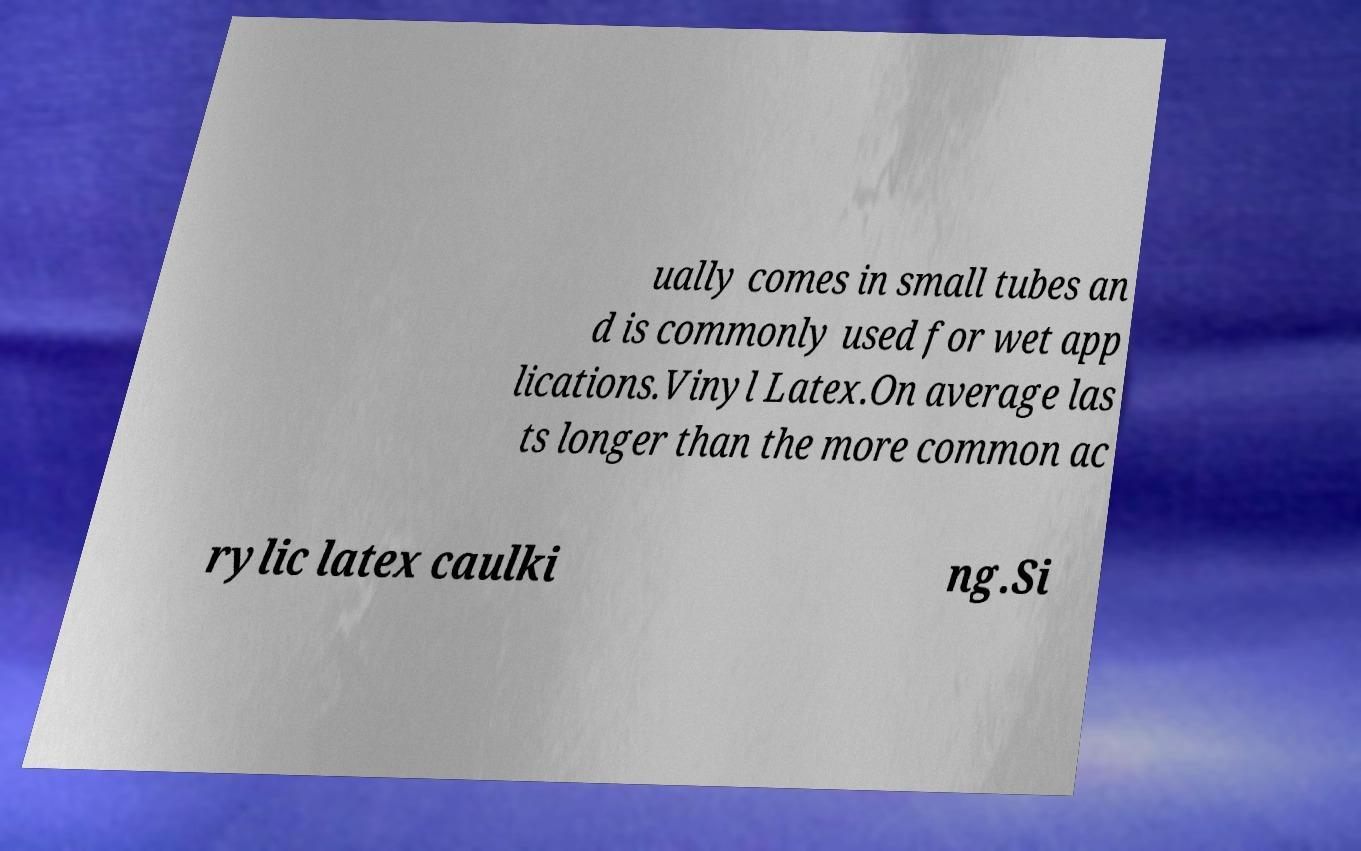Please read and relay the text visible in this image. What does it say? ually comes in small tubes an d is commonly used for wet app lications.Vinyl Latex.On average las ts longer than the more common ac rylic latex caulki ng.Si 